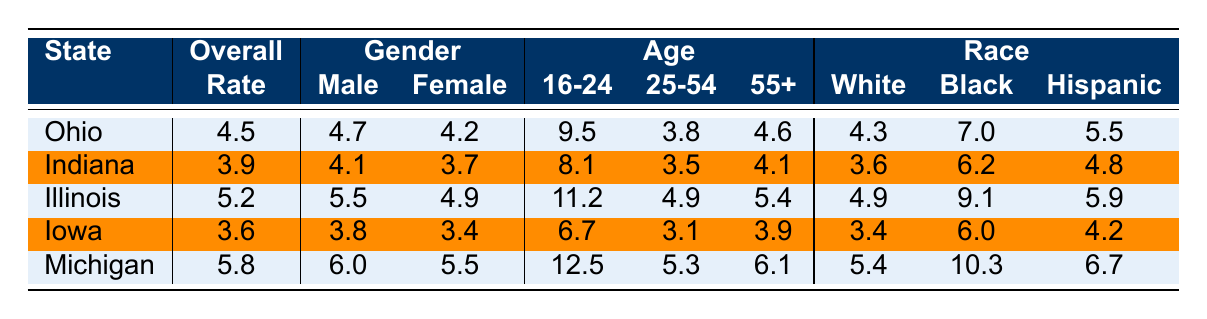What is the overall unemployment rate for Indiana? Indiana's overall unemployment rate is directly provided in the table under the column labeled "Overall". The value listed for Indiana is 3.9.
Answer: 3.9 Which state has the highest unemployment rate among the listed states? To find the highest unemployment rate, I compare the overall rates listed for all the states: Ohio (4.5), Indiana (3.9), Illinois (5.2), Iowa (3.6), and Michigan (5.8). The highest value among these is Michigan at 5.8.
Answer: Michigan, 5.8 What is the male unemployment rate in Ohio compared to the female unemployment rate in the same state? The male unemployment rate in Ohio is listed as 4.7, while the female unemployment rate is 4.2. By comparing these two values, it is evident that the male rate is slightly higher than the female rate.
Answer: Male: 4.7, Female: 4.2 What is the difference in unemployment rates between the age group 16-24 and the age group 25-54 in Illinois? In Illinois, the unemployment rate for the 16-24 age group is 11.2, and for the 25-54 age group, it is 4.9. The difference can be calculated by subtracting the latter from the former: 11.2 - 4.9 = 6.3.
Answer: 6.3 Is the unemployment rate for Black individuals in Michigan higher than the unemployment rate for Hispanic individuals there? The unemployment rate for Black individuals in Michigan is 10.3, while for Hispanic individuals it is 6.7. Since 10.3 is greater than 6.7, the statement is true.
Answer: Yes What is the average unemployment rate for males across all the states? The rates for males are: Ohio (4.7), Indiana (4.1), Illinois (5.5), Iowa (3.8), and Michigan (6.0). To find the average, I sum these rates: 4.7 + 4.1 + 5.5 + 3.8 + 6.0 = 24.1, and then divide by the number of states: 24.1 / 5 = 4.82.
Answer: 4.82 Which state has the lowest unemployment rate for the age group 55+? The unemployment rates for the age group 55+ in the states listed are: Ohio (4.6), Indiana (4.1), Illinois (5.4), Iowa (3.9), and Michigan (6.1). The lowest value among these is Iowa with 3.9.
Answer: Iowa, 3.9 Are the unemployment rates for females in Illinois higher than for females in Ohio? The unemployment rate for females in Illinois is 4.9, while in Ohio, it is 4.2. Since 4.9 is greater than 4.2, the statement is true.
Answer: Yes 